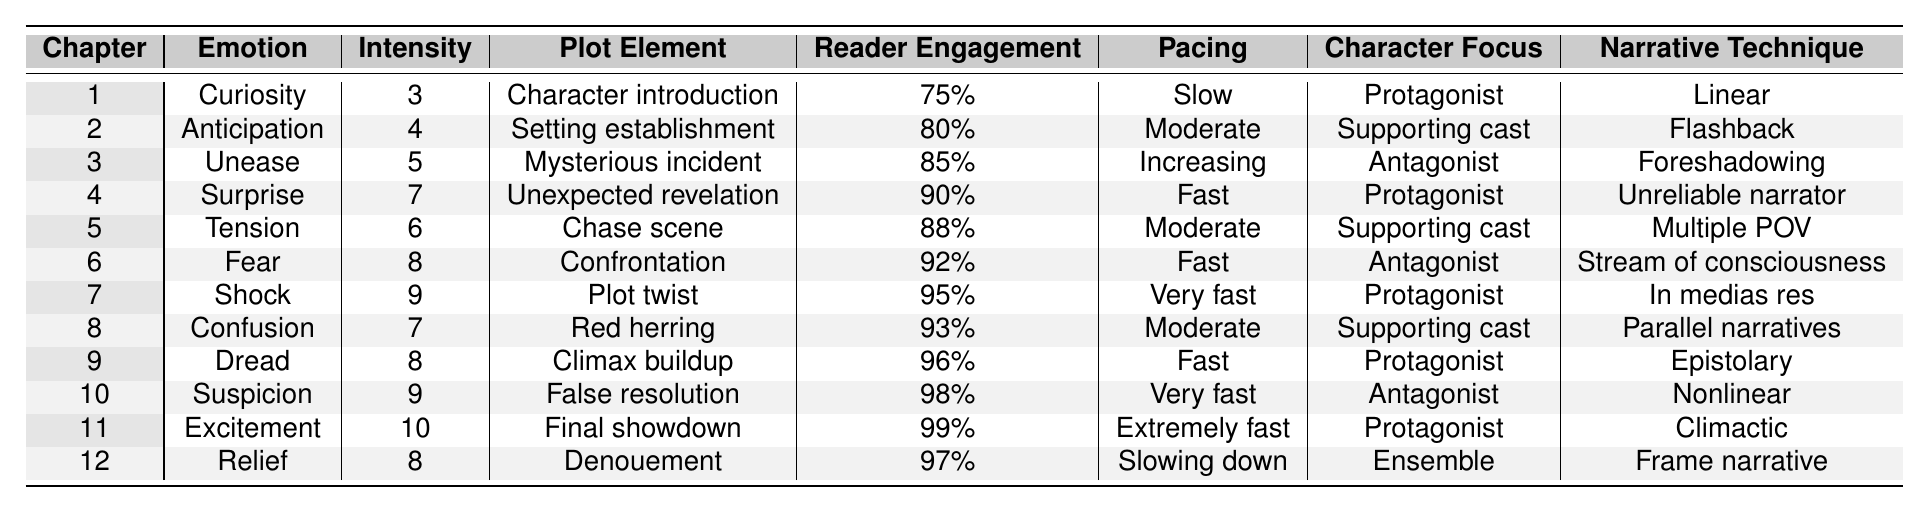What emotion is associated with Chapter 6? Looking at the "Emotion" column for Chapter 6, the value is "Fear."
Answer: Fear Which chapter has the highest reader engagement? In the "Reader Engagement" column, Chapter 11 has the highest value at 99%.
Answer: Chapter 11 What is the intensity of the emotion in Chapter 4? The intensity for Chapter 4, referring to the "Intensity" column, is 7.
Answer: 7 In which chapters do readers experience "Suspicion" and "Dread"? "Suspicion" occurs in Chapter 10 and "Dread" occurs in Chapter 9; both can be found in the "Emotion" column.
Answer: Chapters 9 and 10 What is the average intensity of emotions from Chapters 1 to 3? The intensity values for Chapters 1 to 3 are 3, 4, and 5. The sum is 3 + 4 + 5 = 12, and the average is 12 / 3 = 4.
Answer: 4 Is there a chapter where "Confusion" is experienced with a pacing labeled as "Fast"? Looking through the table, "Confusion" appears in Chapter 8, which has a pacing of "Moderate," not "Fast." Thus, the statement is false.
Answer: No Which chapter features a "Final showdown" and what is its pacing? Chapter 11 features the "Final showdown" and has a pacing labeled as "Extremely fast."
Answer: Extremely fast How does the pacing change from Chapter 3 to Chapter 6? Chapter 3 has "Increasing" pacing, while Chapter 6 is categorized as "Fast." This indicates a shift from a building pace to a more rapid one.
Answer: Increasing to Fast In which chapter does the "Protagonist" primarily focus while experiencing "Excitement"? Chapter 11 focuses on the "Protagonist" while experiencing "Excitement." This is noted in both the "Character Focus" and "Emotion" columns.
Answer: Chapter 11 Can you find a chapter where the emotional intensity is greater than or equal to 8 and "Tension" is the emotion? In the table, Chapter 6 has an intensity of 8; however, it shows "Fear" as the emotion. "Tension" appears in Chapter 5, which has an intensity of 6, therefore, the answer is no.
Answer: No 